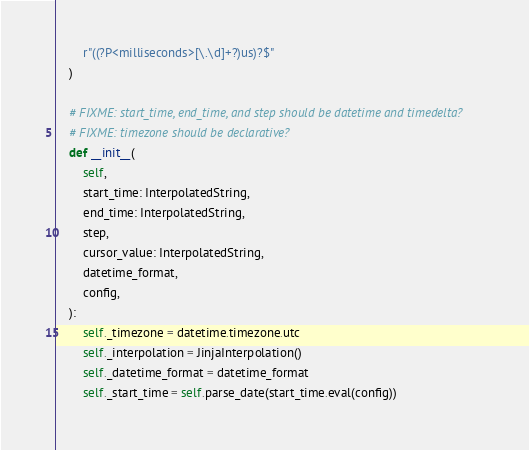<code> <loc_0><loc_0><loc_500><loc_500><_Python_>        r"((?P<milliseconds>[\.\d]+?)us)?$"
    )

    # FIXME: start_time, end_time, and step should be datetime and timedelta?
    # FIXME: timezone should be declarative?
    def __init__(
        self,
        start_time: InterpolatedString,
        end_time: InterpolatedString,
        step,
        cursor_value: InterpolatedString,
        datetime_format,
        config,
    ):
        self._timezone = datetime.timezone.utc
        self._interpolation = JinjaInterpolation()
        self._datetime_format = datetime_format
        self._start_time = self.parse_date(start_time.eval(config))</code> 